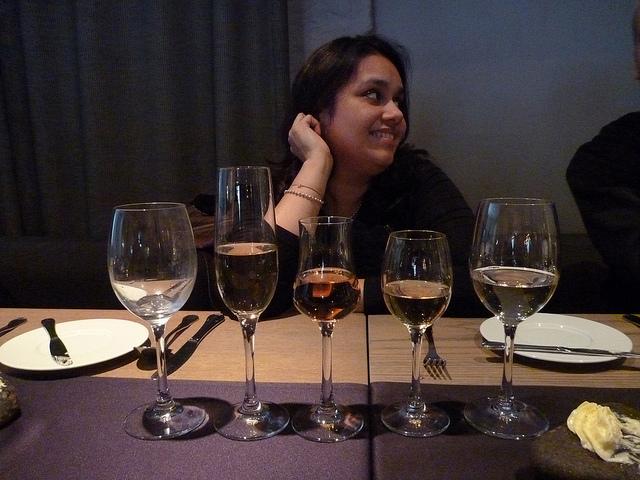What type of expression does the woman have?
Concise answer only. Smile. How many pieces of cutlery are in the picture?
Be succinct. 6. Are all the wine glasses full?
Keep it brief. No. Which glass has white wine?
Be succinct. Right. Is the glass half full?
Give a very brief answer. Yes. What color is the wine?
Keep it brief. White. Is this a display?
Keep it brief. No. What color of shirt is the closest person wearing?
Answer briefly. Black. How many glasses are on the table?
Give a very brief answer. 5. What is on her face?
Quick response, please. Smile. How many people are in the picture?
Write a very short answer. 1. 